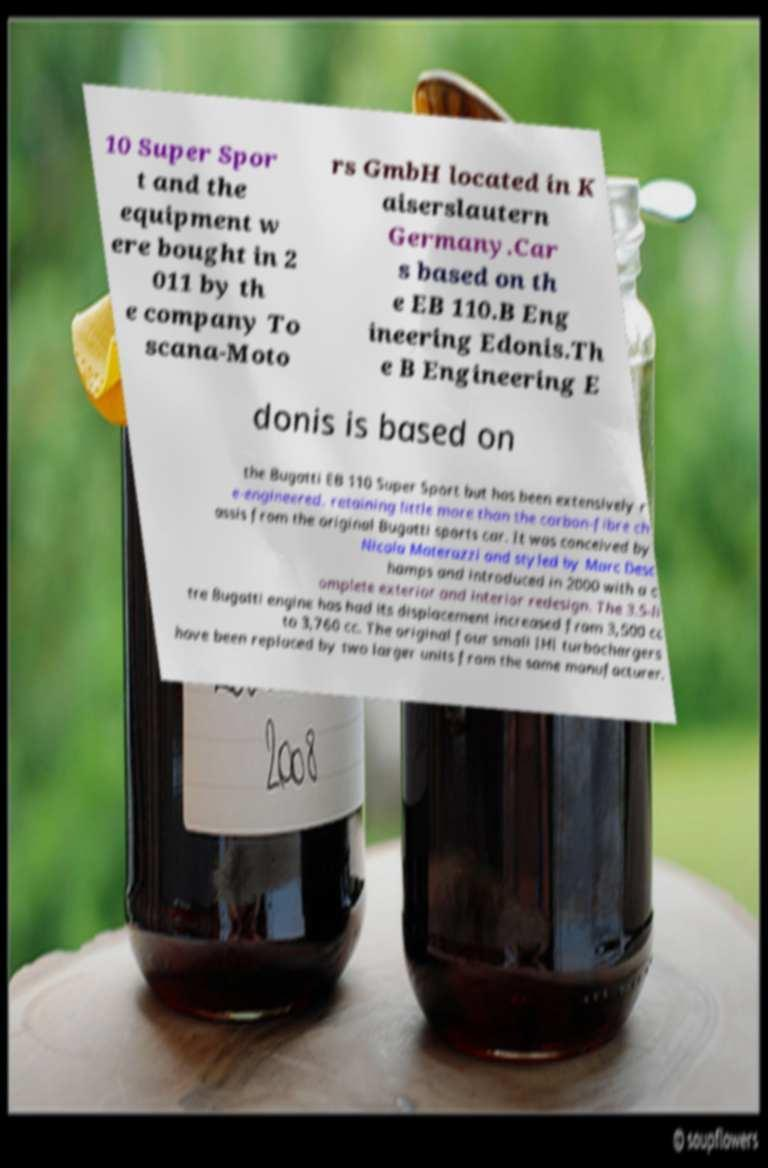Please identify and transcribe the text found in this image. 10 Super Spor t and the equipment w ere bought in 2 011 by th e company To scana-Moto rs GmbH located in K aiserslautern Germany.Car s based on th e EB 110.B Eng ineering Edonis.Th e B Engineering E donis is based on the Bugatti EB 110 Super Sport but has been extensively r e-engineered, retaining little more than the carbon-fibre ch assis from the original Bugatti sports car. It was conceived by Nicola Materazzi and styled by Marc Desc hamps and introduced in 2000 with a c omplete exterior and interior redesign. The 3.5-li tre Bugatti engine has had its displacement increased from 3,500 cc to 3,760 cc. The original four small IHI turbochargers have been replaced by two larger units from the same manufacturer. 